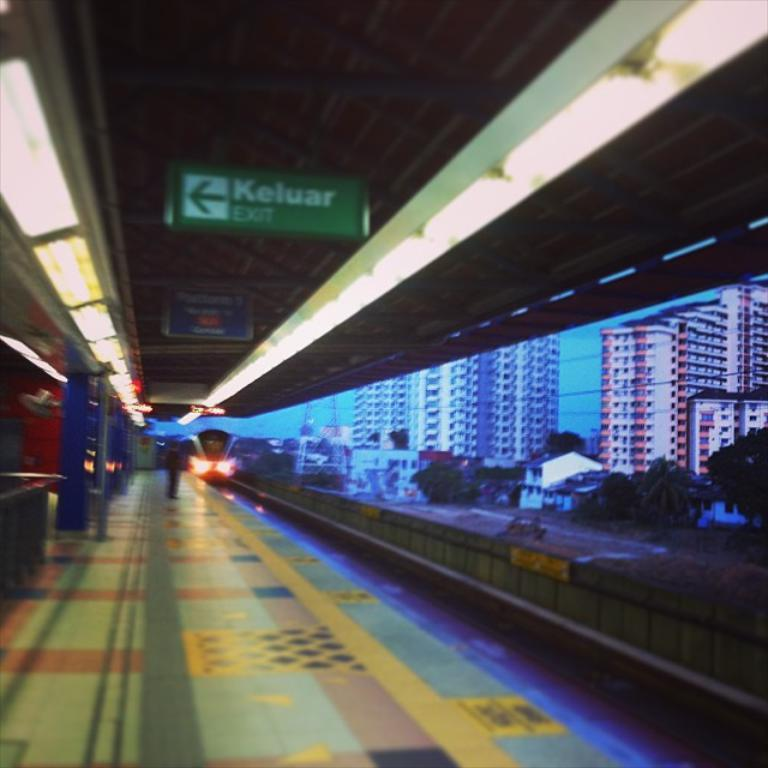What type of structure is present in the image? There is a railway station shed in the image. What is located near the railway station shed? There is a platform in the image. What mode of transportation can be seen in the image? There is a train on the track in the image. What type of vegetation is visible in the image? There are trees visible in the image. What other structures are present in the image? There are buildings in the image. What part of the natural environment is visible in the image? The sky is visible in the image. What type of dress is hanging on the top of the train in the image? There is no dress present in the image, and the train does not have a top where a dress could be hanging. 